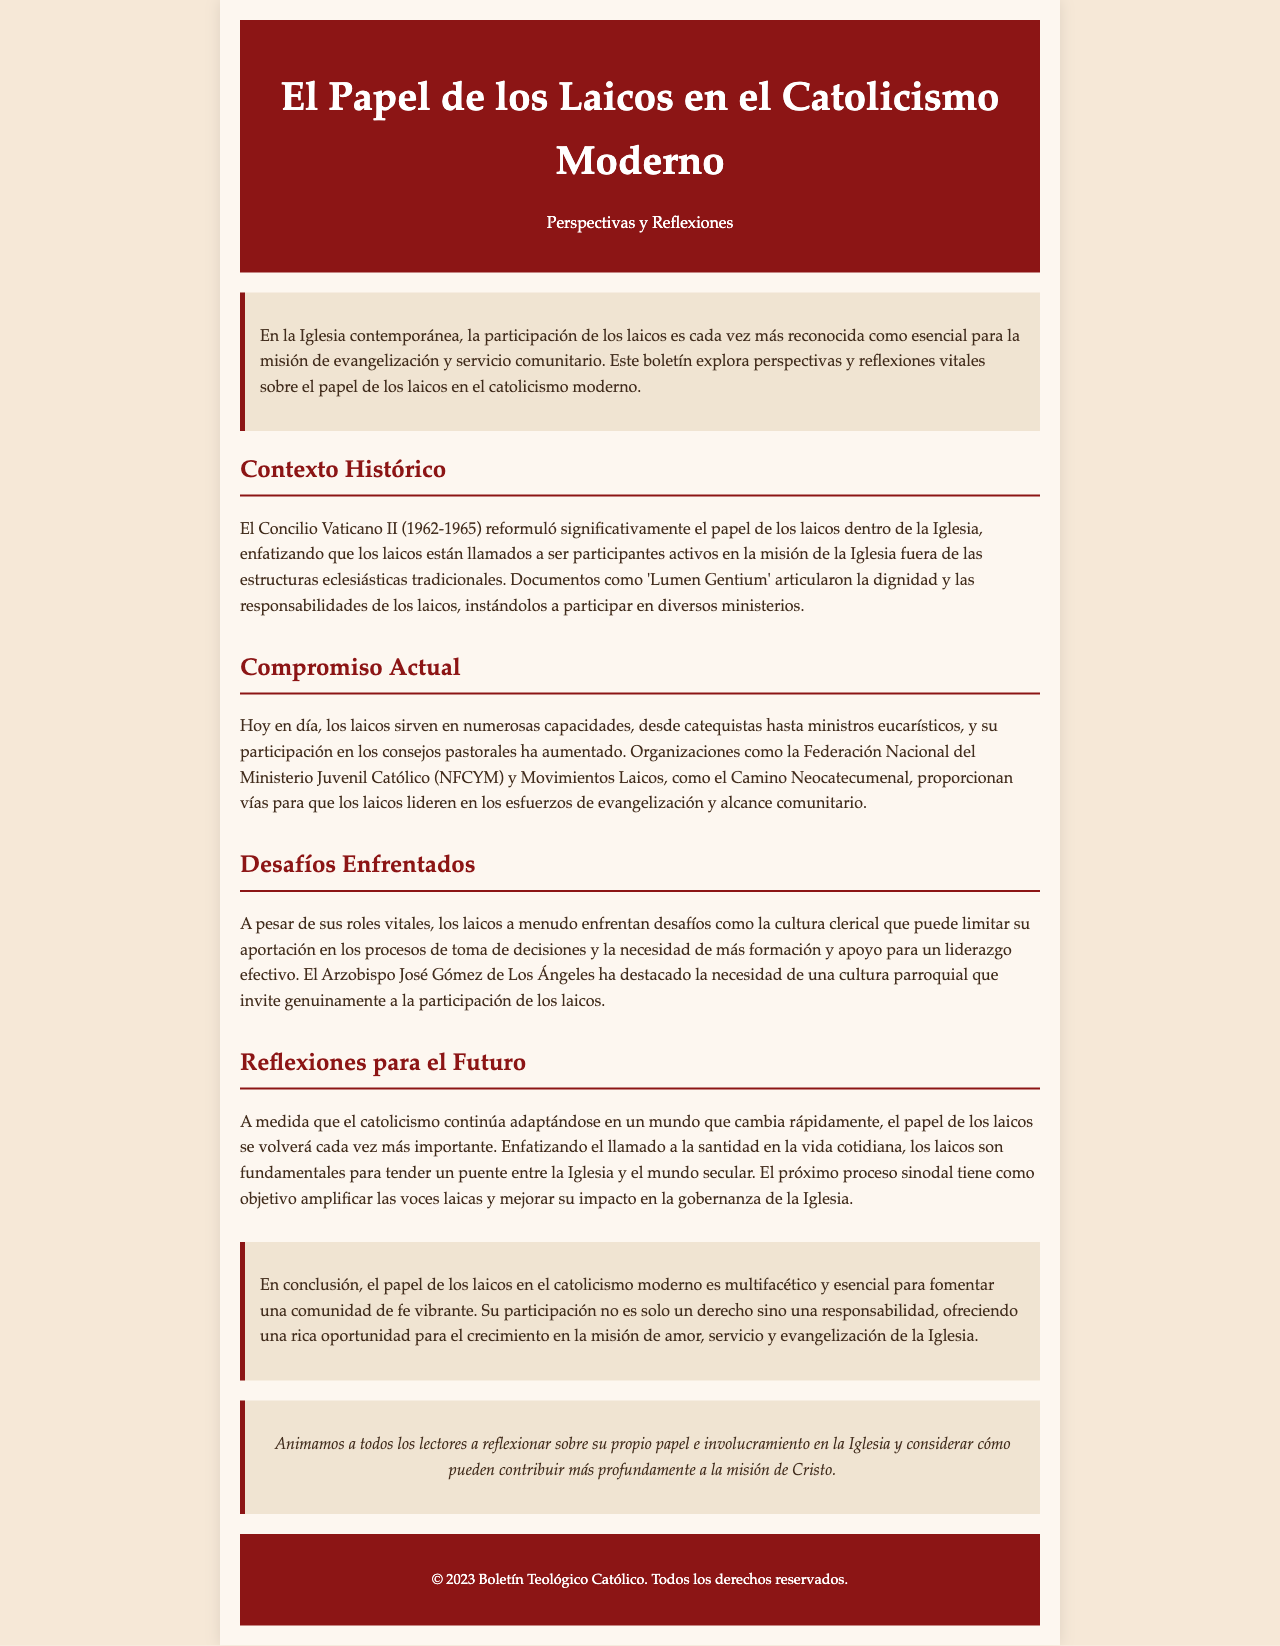¿Qué evento reformuló el papel de los laicos? El Concilio Vaticano II reformuló significativamente el papel de los laicos dentro de la Iglesia.
Answer: Concilio Vaticano II ¿Cuál es un organismo que apoya a los laicos en su participación? La Federación Nacional del Ministerio Juvenil Católico es una de las organizaciones que apoyan a los laicos.
Answer: Federación Nacional del Ministerio Juvenil Católico ¿Qué documento destaca las responsabilidades de los laicos? El documento 'Lumen Gentium' articula la dignidad y las responsabilidades de los laicos.
Answer: Lumen Gentium ¿Cuál es uno de los desafíos mencionados que enfrentan los laicos? Los laicos a menudo enfrentan la cultura clerical como un desafío.
Answer: Cultura clerical ¿Qué aspecto se enfatiza para el futuro de los laicos? Se enfatiza el llamado a la santidad en la vida cotidiana.
Answer: Llamado a la santidad ¿Cuál es el objetivo del próximo proceso sinodal? El objetivo es amplificar las voces laicas y mejorar su impacto en la gobernanza de la Iglesia.
Answer: Amplificar las voces laicas ¿Qué se sugiere en la conclusión sobre la participación de los laicos? La participación de los laicos es considerada una responsabilidad.
Answer: Una responsabilidad ¿Qué tipo de ministerios ejercen los laicos actualmente? Los laicos ejercen ministerios como catequistas y ministros eucarísticos.
Answer: Catequistas y ministros eucarísticos 